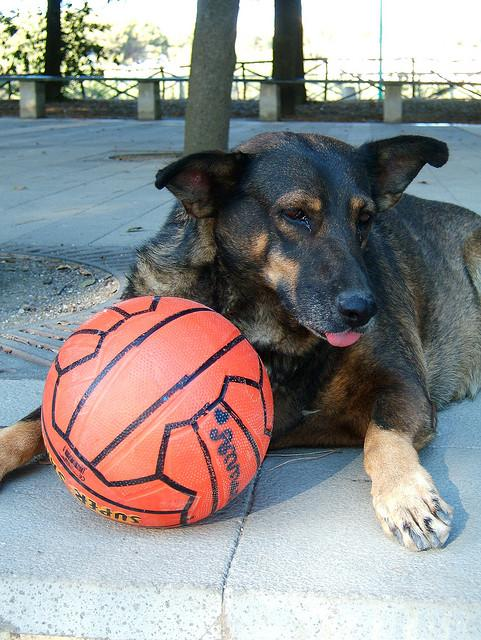What kind of ball is the dog sitting next to on the concrete?

Choices:
A) soccer
B) tennis ball
C) basketball
D) baseball basketball 